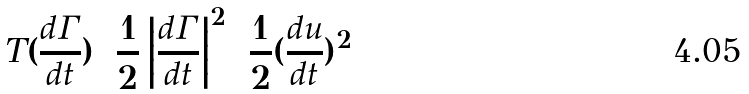<formula> <loc_0><loc_0><loc_500><loc_500>T ( \frac { d \Gamma } { d t } ) = \frac { 1 } { 2 } \left | \frac { d \Gamma } { d t } \right | ^ { 2 } = \frac { 1 } { 2 } ( \frac { d u } { d t } ) ^ { 2 }</formula> 